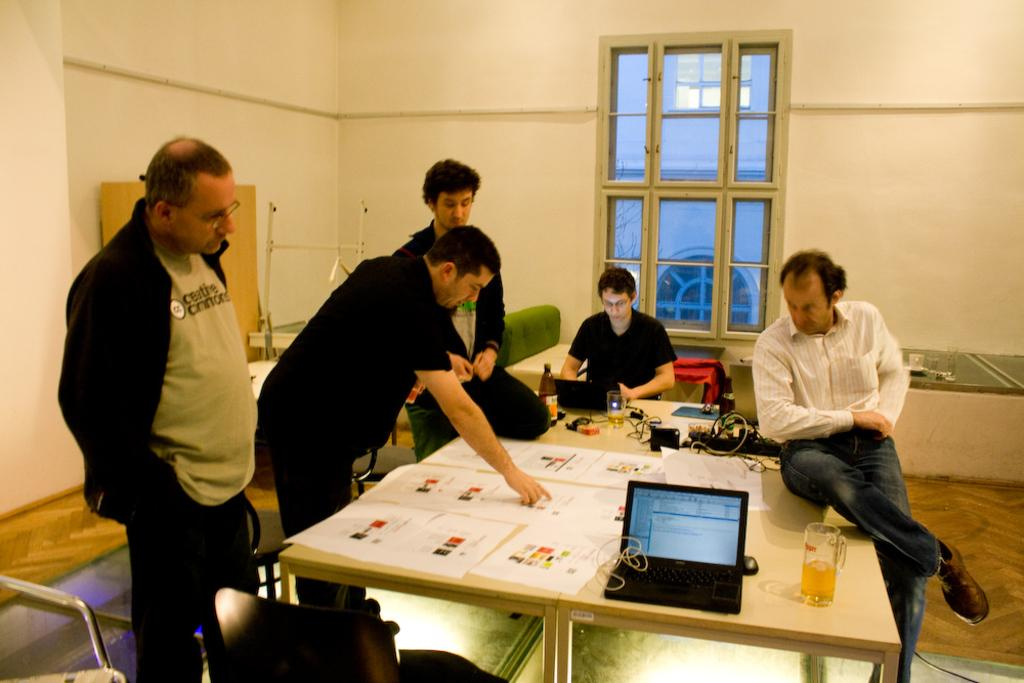How many people are in the image? There is a group of people in the image, but the exact number is not specified. What are the people in the image doing? Some people are standing, while others are sitting. What is on the table in front of the group? There is a laptop, a beverage glass, papers, and cables on the table. What might the people be using the laptop for? It is not clear from the image what the people are using the laptop for, but it could be for work, entertainment, or communication. What time is it in the image? There is no indication of the time in the image. 